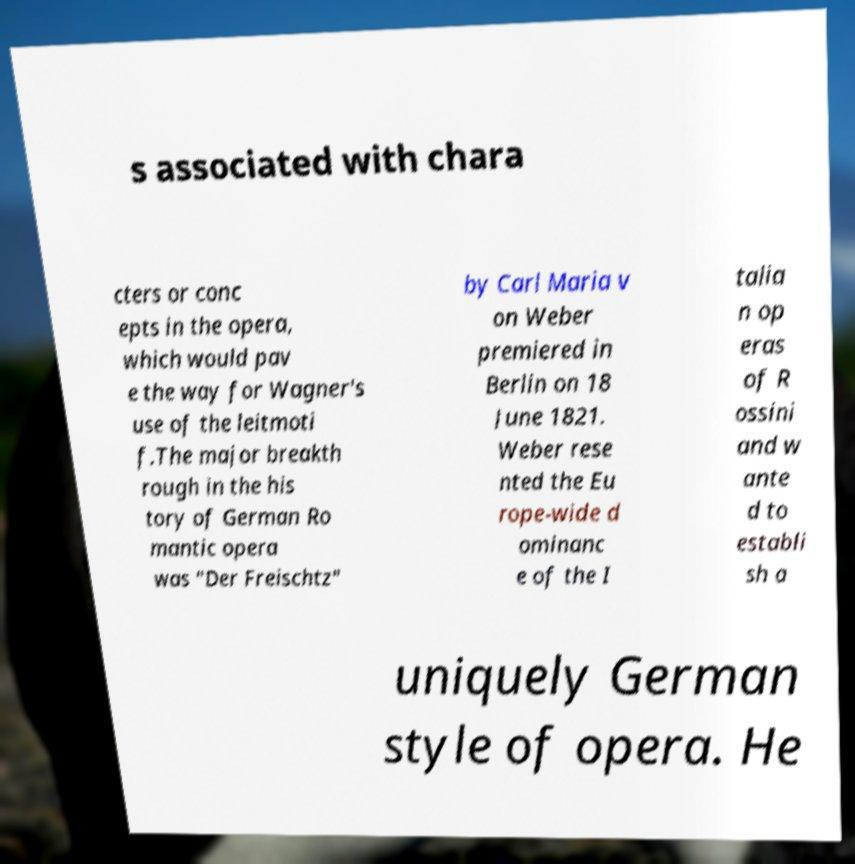There's text embedded in this image that I need extracted. Can you transcribe it verbatim? s associated with chara cters or conc epts in the opera, which would pav e the way for Wagner's use of the leitmoti f.The major breakth rough in the his tory of German Ro mantic opera was "Der Freischtz" by Carl Maria v on Weber premiered in Berlin on 18 June 1821. Weber rese nted the Eu rope-wide d ominanc e of the I talia n op eras of R ossini and w ante d to establi sh a uniquely German style of opera. He 